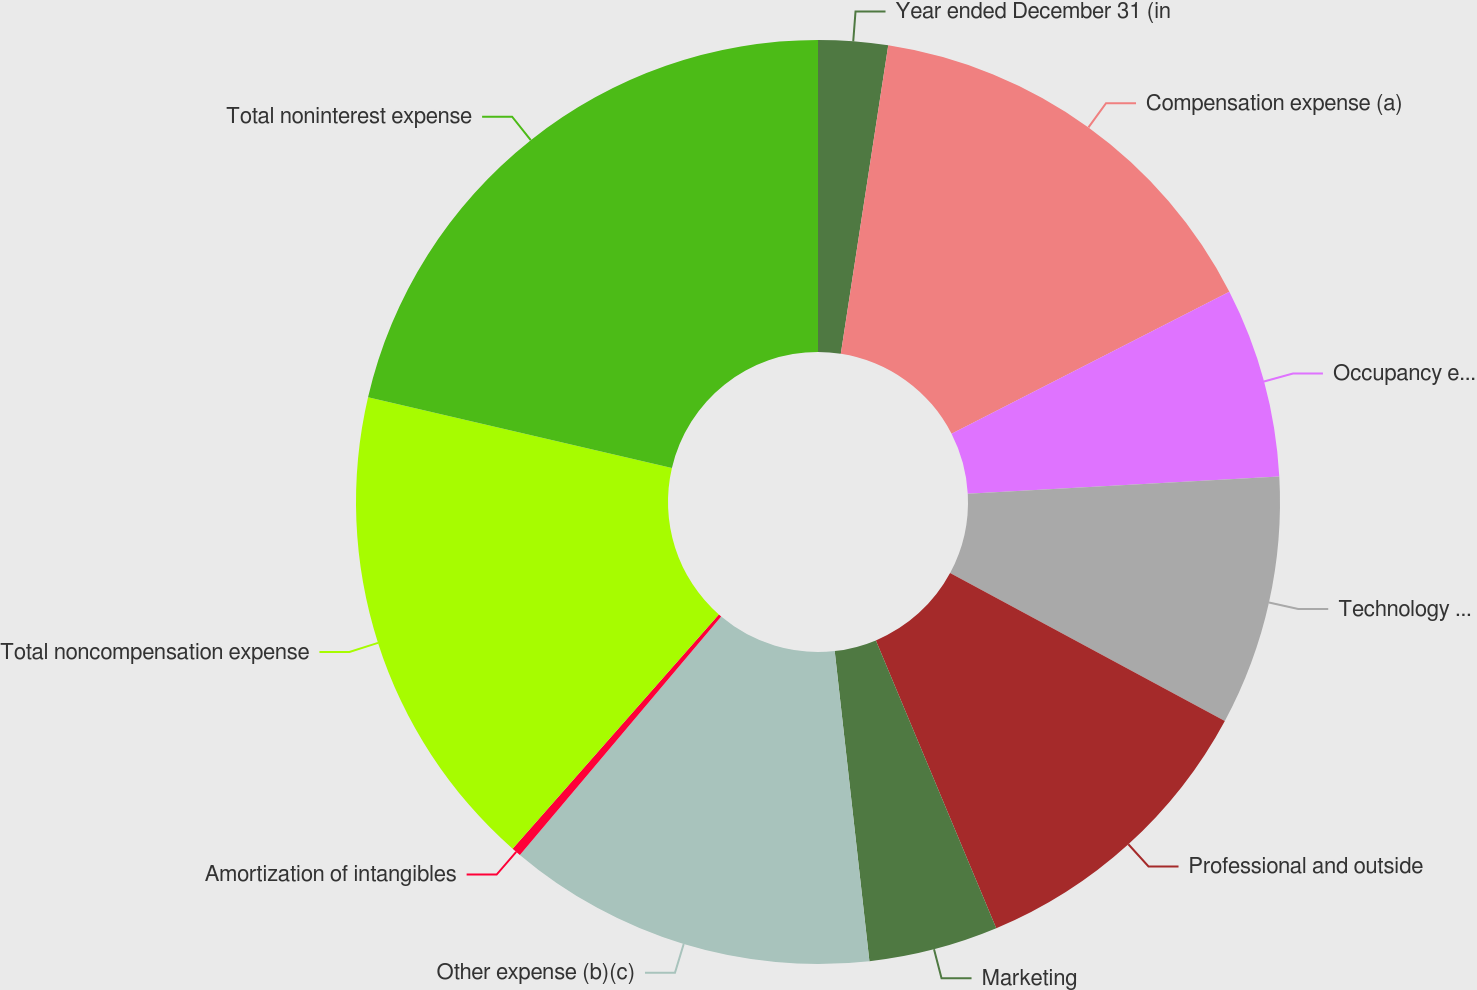Convert chart. <chart><loc_0><loc_0><loc_500><loc_500><pie_chart><fcel>Year ended December 31 (in<fcel>Compensation expense (a)<fcel>Occupancy expense<fcel>Technology communications and<fcel>Professional and outside<fcel>Marketing<fcel>Other expense (b)(c)<fcel>Amortization of intangibles<fcel>Total noncompensation expense<fcel>Total noninterest expense<nl><fcel>2.43%<fcel>15.05%<fcel>6.64%<fcel>8.74%<fcel>10.84%<fcel>4.53%<fcel>12.94%<fcel>0.33%<fcel>17.15%<fcel>21.36%<nl></chart> 